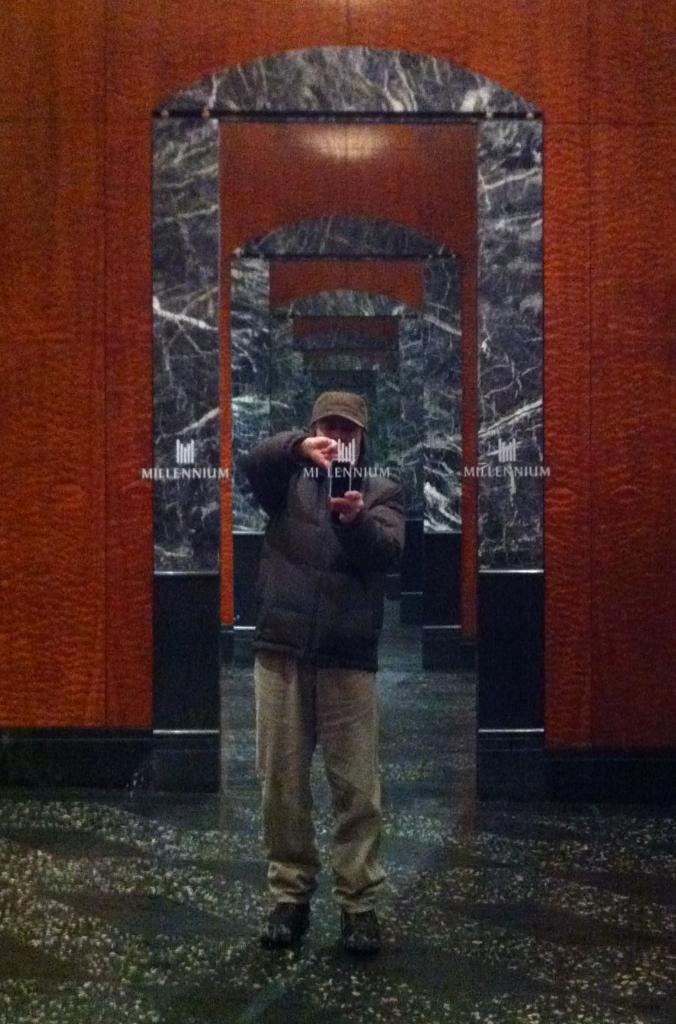Describe this image in one or two sentences. In this picture we can see a man, he is standing and he wore a cap. 